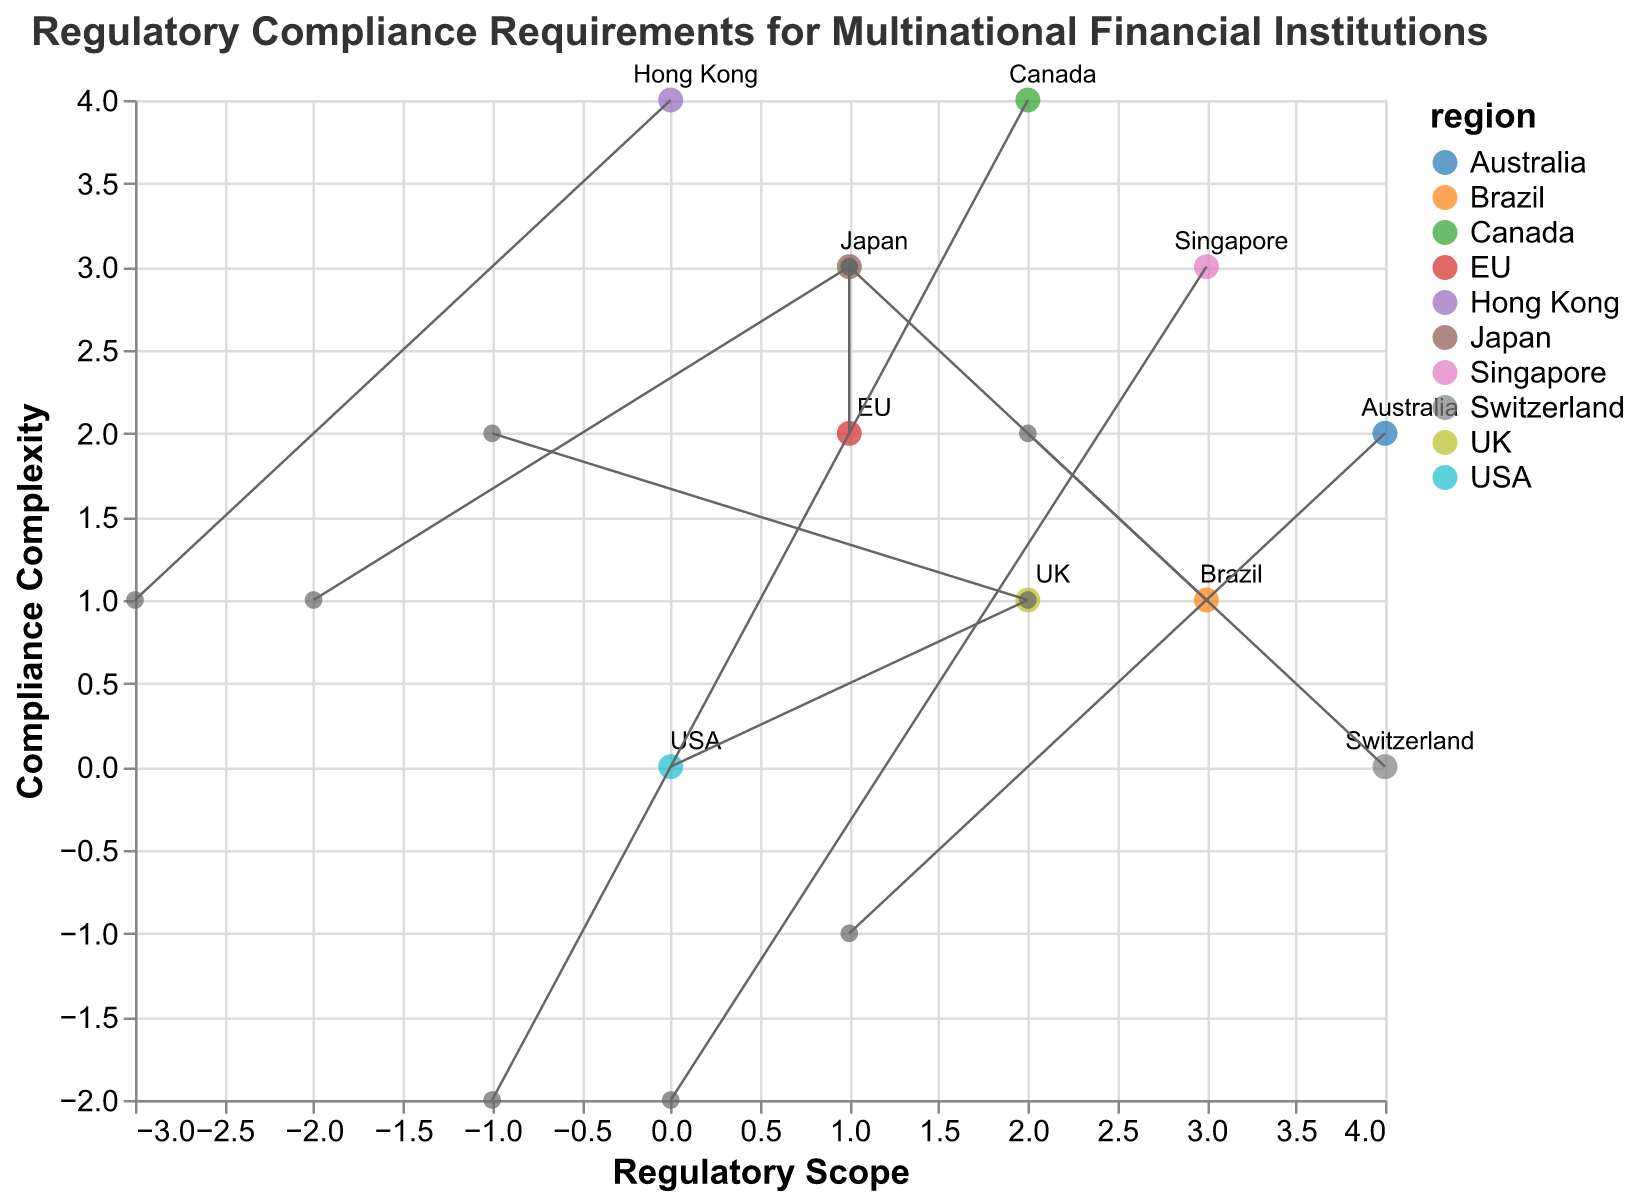What is the title of the plot? The title is displayed at the top of the plot. It reads "Regulatory Compliance Requirements for Multinational Financial Institutions."
Answer: Regulatory Compliance Requirements for Multinational Financial Institutions How many regions are represented in the plot? Count the number of unique regions listed in the data labels. There are 10 distinct regions.
Answer: 10 Which region has the highest Compliance Complexity? Look at the y-axis values and find the highest point. The EU, with GDPR, is positioned at y = 3.
Answer: EU What are the x and y coordinates for the USA? Locate the point labeled "USA" (Dodd-Frank Act). The coordinates are (0, 0).
Answer: (0, 0) Which region shows a negative shift in the Regulatory Scope? Look for regions with a negative x-direction (u) value. The UK, with -1, and Japan, with -2, show this shift.
Answer: UK and Japan Which region has the vector with the largest magnitude? Calculate each vector magnitude using the formula √(u² + v²). Switzerland has the largest vector (2, 2), giving a magnitude of √(4 + 4) = √8 = 2√2.
Answer: Switzerland What is the overall trend in Compliance Complexity for Brazil? Identify the start and end y-values for Brazil. The vector (1, 3) starts at (3, 1). The y-value increases from 1 to 4.
Answer: Increasing What is the difference in Regulatory Scope changes between Australia and Switzerland? Australia's u = 1 and Switzerland's u = 2. Subtract the values: 2 - 1 = 1.
Answer: 1 Which region has the most significant shift towards decreasing Compliance Complexity? Look for the largest negative y-direction (v) value. Singapore has the most significant decrease at -2.
Answer: Singapore What can be inferred about the regulatory requirements in Hong Kong compared to Canada in terms of vector direction? Both have negative x-values indicating reducing Regulatory Scope, but Hong Kong's y value is increasing (v = 1) while Canada's y value is decreasing (v = -2). This shows different Compliance Complexity directions.
Answer: Hong Kong: Reducing scope, increasing complexity; Canada: Reducing scope, decreasing complexity 